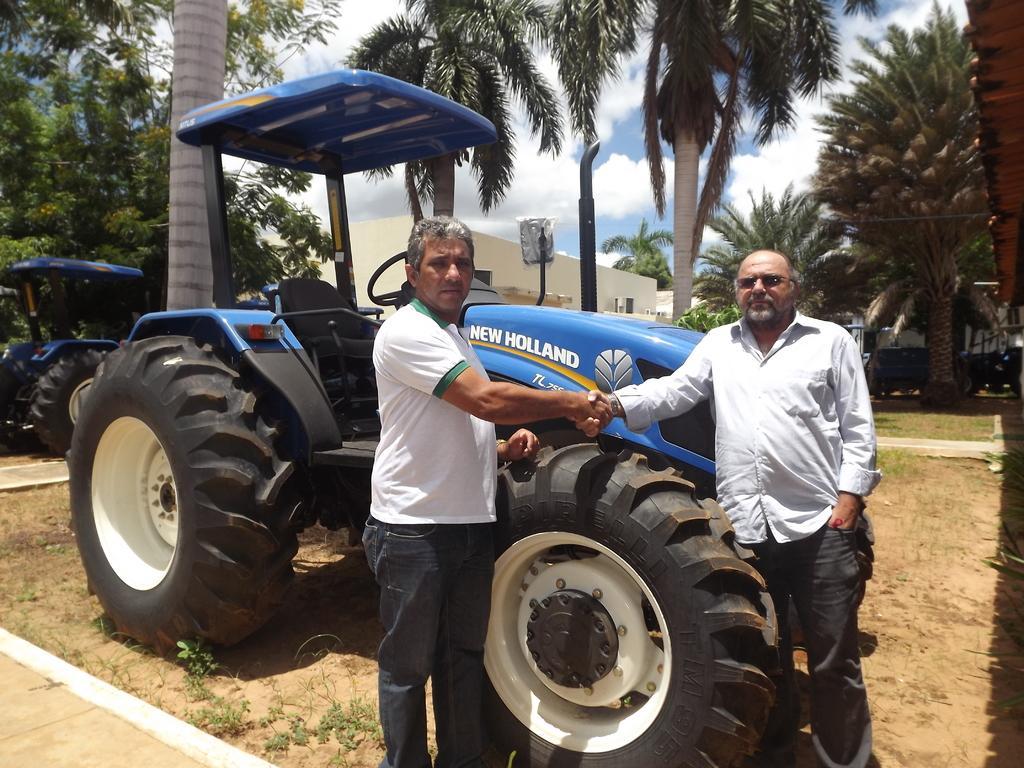How would you summarize this image in a sentence or two? In this picture we can see two men shaking hands and standing on the ground, trees, buildings, tractors and in the background we can see the sky with clouds. 